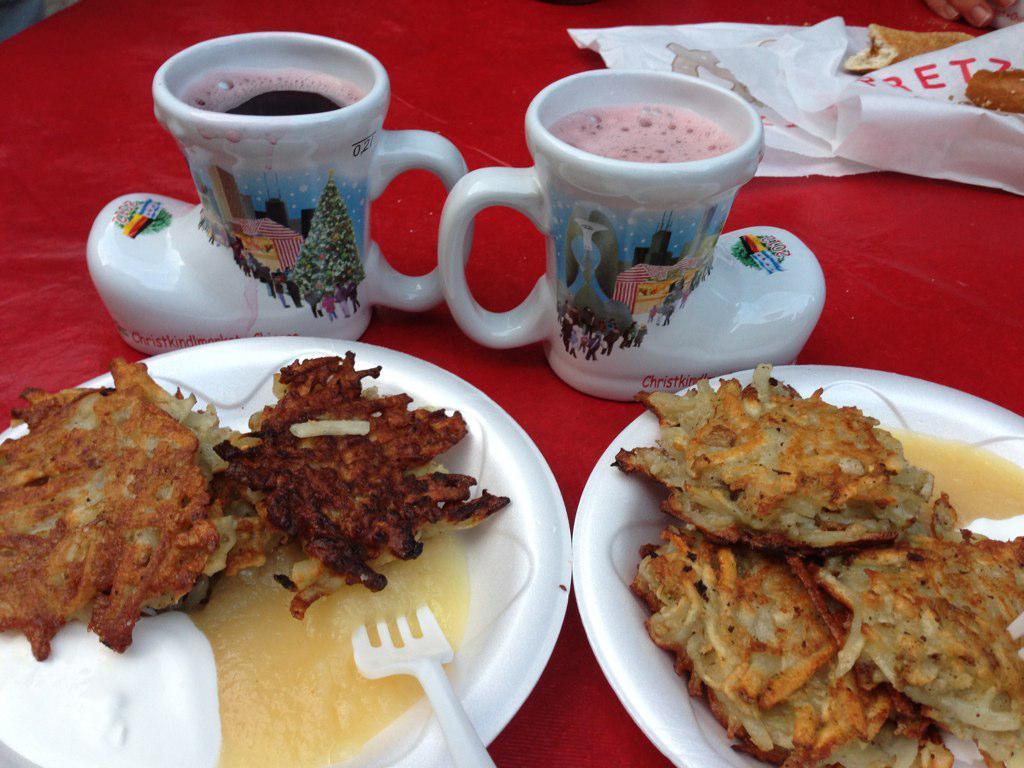How would you summarize this image in a sentence or two? In the picture I can see the table which is covered with a red color cloth. I can see two ceramic cups and plates are kept on the table. There are plastic covers on the table on the top right side. 